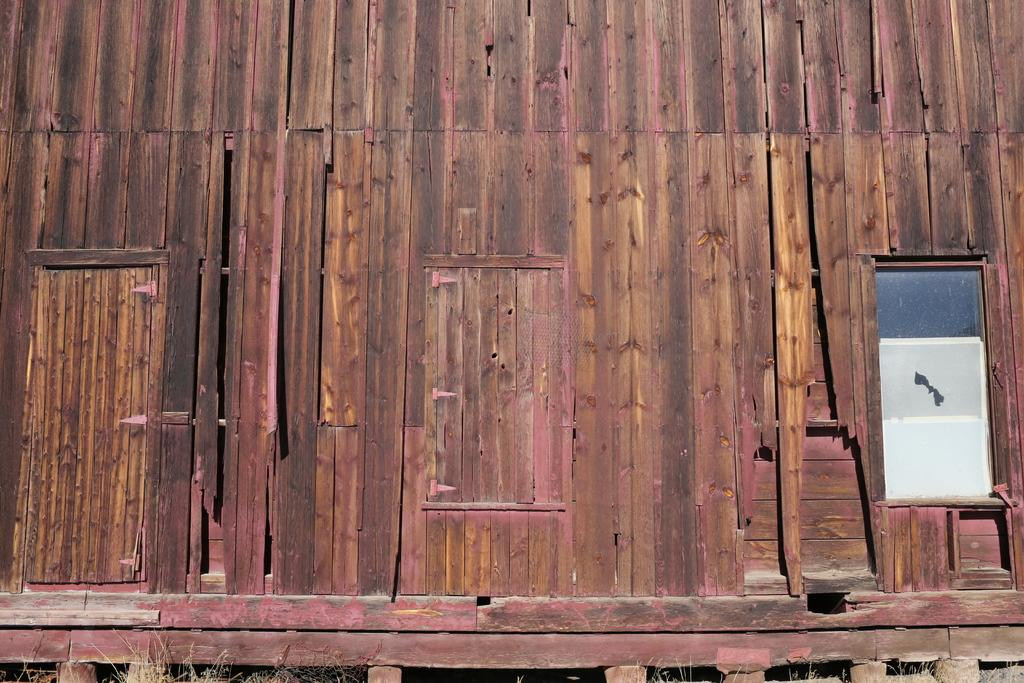What type of house is shown in the image? The image shows a wooden house. From which angle is the house viewed? The house is viewed from the front. Where is the door located on the house? The door is on the left side of the image. Is there any other opening visible on the house? Yes, there is a window on the right side of the image. What type of sail can be seen on the roof of the house? There is no sail present on the roof of the house in the image. 